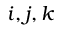<formula> <loc_0><loc_0><loc_500><loc_500>i , j , k</formula> 